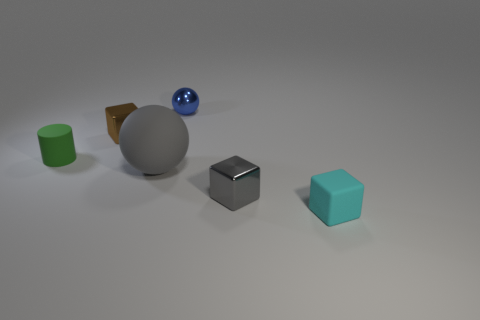What is the shape of the small rubber object behind the small gray object?
Your response must be concise. Cylinder. There is a cube left of the gray matte ball; does it have the same size as the ball left of the blue metallic object?
Your response must be concise. No. Are there more brown shiny cubes that are on the right side of the cyan block than tiny blue balls in front of the small blue metallic ball?
Ensure brevity in your answer.  No. Do the small cylinder and the large thing have the same color?
Your response must be concise. No. What is the material of the block that is both behind the small cyan block and in front of the brown thing?
Provide a short and direct response. Metal. Does the tiny block that is right of the small gray shiny block have the same material as the gray thing on the right side of the large ball?
Provide a succinct answer. No. There is a gray metal thing that is in front of the small matte thing that is behind the tiny cyan matte cube; what size is it?
Give a very brief answer. Small. There is a small cyan thing that is the same shape as the small gray metal object; what is its material?
Ensure brevity in your answer.  Rubber. There is a small green thing that is behind the large thing; does it have the same shape as the tiny metal object that is in front of the green thing?
Make the answer very short. No. Does the small thing in front of the gray metal object have the same material as the green cylinder?
Give a very brief answer. Yes. 